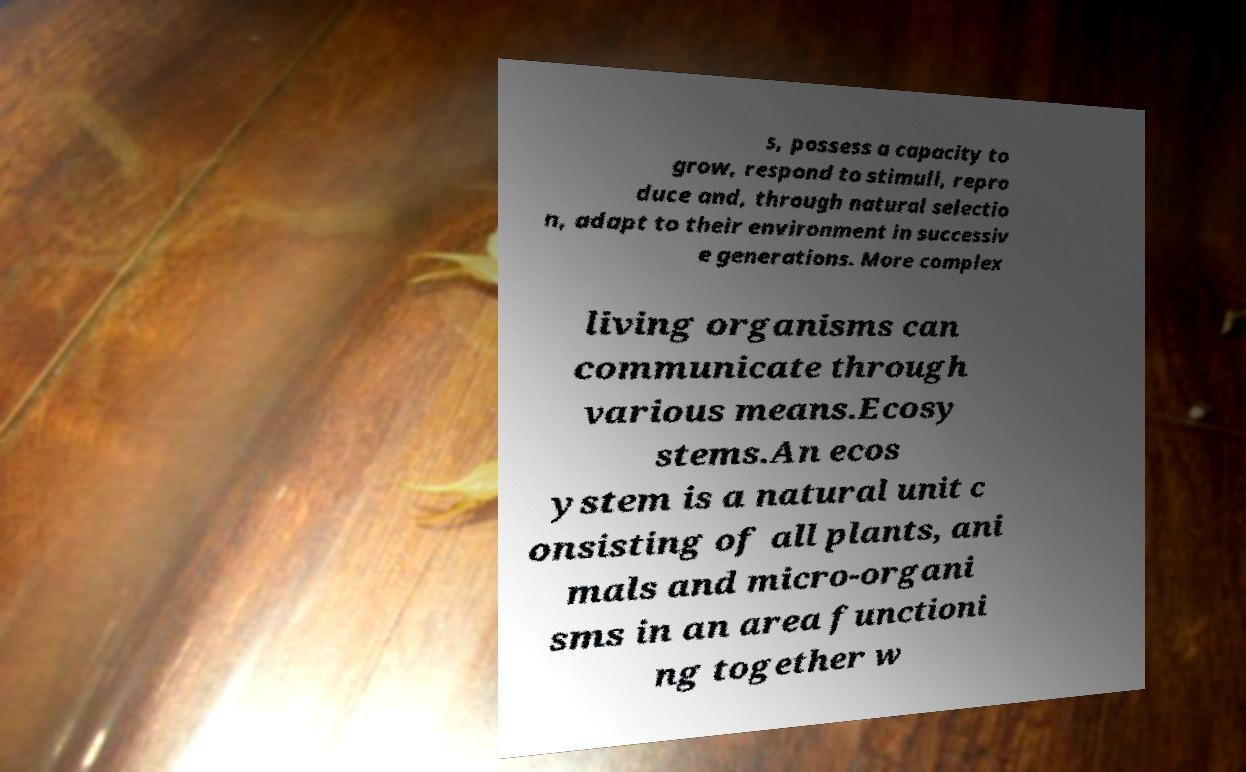Can you accurately transcribe the text from the provided image for me? s, possess a capacity to grow, respond to stimuli, repro duce and, through natural selectio n, adapt to their environment in successiv e generations. More complex living organisms can communicate through various means.Ecosy stems.An ecos ystem is a natural unit c onsisting of all plants, ani mals and micro-organi sms in an area functioni ng together w 